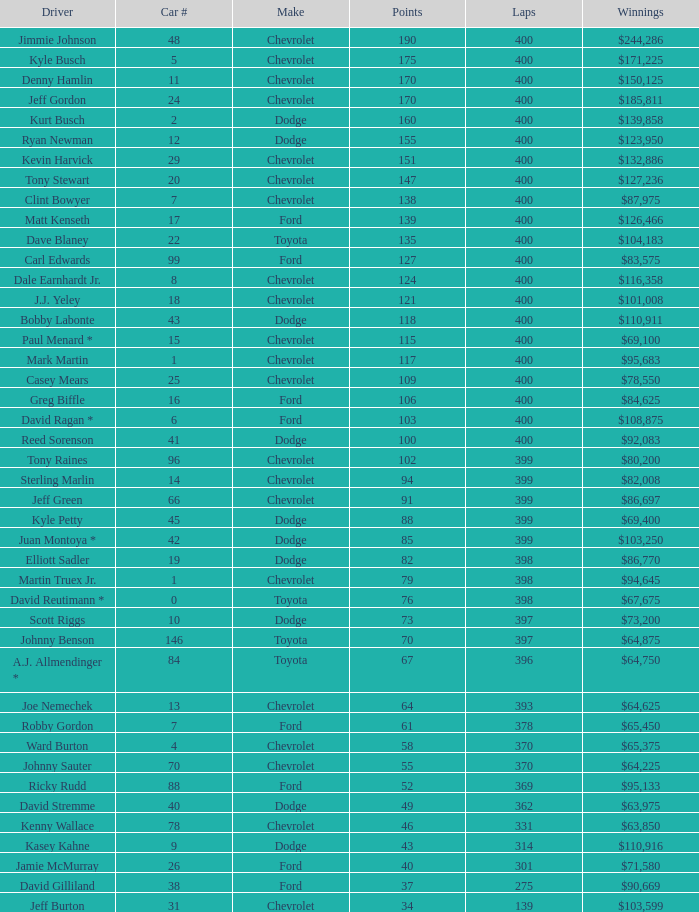What is the car number that has less than 369 laps for a Dodge with more than 49 points? None. Could you parse the entire table as a dict? {'header': ['Driver', 'Car #', 'Make', 'Points', 'Laps', 'Winnings'], 'rows': [['Jimmie Johnson', '48', 'Chevrolet', '190', '400', '$244,286'], ['Kyle Busch', '5', 'Chevrolet', '175', '400', '$171,225'], ['Denny Hamlin', '11', 'Chevrolet', '170', '400', '$150,125'], ['Jeff Gordon', '24', 'Chevrolet', '170', '400', '$185,811'], ['Kurt Busch', '2', 'Dodge', '160', '400', '$139,858'], ['Ryan Newman', '12', 'Dodge', '155', '400', '$123,950'], ['Kevin Harvick', '29', 'Chevrolet', '151', '400', '$132,886'], ['Tony Stewart', '20', 'Chevrolet', '147', '400', '$127,236'], ['Clint Bowyer', '7', 'Chevrolet', '138', '400', '$87,975'], ['Matt Kenseth', '17', 'Ford', '139', '400', '$126,466'], ['Dave Blaney', '22', 'Toyota', '135', '400', '$104,183'], ['Carl Edwards', '99', 'Ford', '127', '400', '$83,575'], ['Dale Earnhardt Jr.', '8', 'Chevrolet', '124', '400', '$116,358'], ['J.J. Yeley', '18', 'Chevrolet', '121', '400', '$101,008'], ['Bobby Labonte', '43', 'Dodge', '118', '400', '$110,911'], ['Paul Menard *', '15', 'Chevrolet', '115', '400', '$69,100'], ['Mark Martin', '1', 'Chevrolet', '117', '400', '$95,683'], ['Casey Mears', '25', 'Chevrolet', '109', '400', '$78,550'], ['Greg Biffle', '16', 'Ford', '106', '400', '$84,625'], ['David Ragan *', '6', 'Ford', '103', '400', '$108,875'], ['Reed Sorenson', '41', 'Dodge', '100', '400', '$92,083'], ['Tony Raines', '96', 'Chevrolet', '102', '399', '$80,200'], ['Sterling Marlin', '14', 'Chevrolet', '94', '399', '$82,008'], ['Jeff Green', '66', 'Chevrolet', '91', '399', '$86,697'], ['Kyle Petty', '45', 'Dodge', '88', '399', '$69,400'], ['Juan Montoya *', '42', 'Dodge', '85', '399', '$103,250'], ['Elliott Sadler', '19', 'Dodge', '82', '398', '$86,770'], ['Martin Truex Jr.', '1', 'Chevrolet', '79', '398', '$94,645'], ['David Reutimann *', '0', 'Toyota', '76', '398', '$67,675'], ['Scott Riggs', '10', 'Dodge', '73', '397', '$73,200'], ['Johnny Benson', '146', 'Toyota', '70', '397', '$64,875'], ['A.J. Allmendinger *', '84', 'Toyota', '67', '396', '$64,750'], ['Joe Nemechek', '13', 'Chevrolet', '64', '393', '$64,625'], ['Robby Gordon', '7', 'Ford', '61', '378', '$65,450'], ['Ward Burton', '4', 'Chevrolet', '58', '370', '$65,375'], ['Johnny Sauter', '70', 'Chevrolet', '55', '370', '$64,225'], ['Ricky Rudd', '88', 'Ford', '52', '369', '$95,133'], ['David Stremme', '40', 'Dodge', '49', '362', '$63,975'], ['Kenny Wallace', '78', 'Chevrolet', '46', '331', '$63,850'], ['Kasey Kahne', '9', 'Dodge', '43', '314', '$110,916'], ['Jamie McMurray', '26', 'Ford', '40', '301', '$71,580'], ['David Gilliland', '38', 'Ford', '37', '275', '$90,669'], ['Jeff Burton', '31', 'Chevrolet', '34', '139', '$103,599']]} 